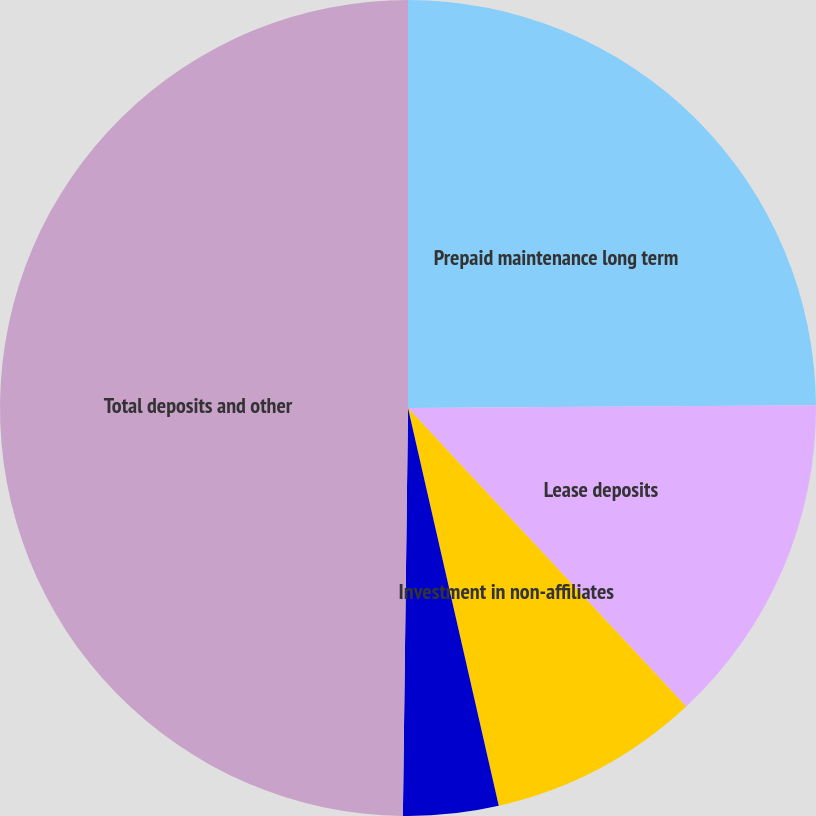Convert chart to OTSL. <chart><loc_0><loc_0><loc_500><loc_500><pie_chart><fcel>Prepaid maintenance long term<fcel>Lease deposits<fcel>Investment in non-affiliates<fcel>Other<fcel>Total deposits and other<nl><fcel>24.89%<fcel>13.17%<fcel>8.37%<fcel>3.77%<fcel>49.8%<nl></chart> 